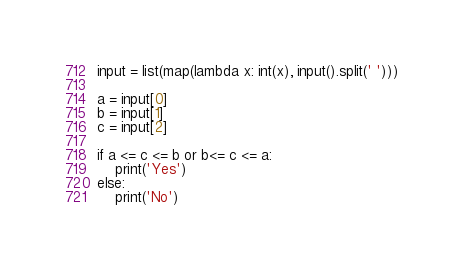Convert code to text. <code><loc_0><loc_0><loc_500><loc_500><_Python_>input = list(map(lambda x: int(x), input().split(' ')))

a = input[0]
b = input[1]
c = input[2]

if a <= c <= b or b<= c <= a:
    print('Yes')
else:
    print('No')</code> 